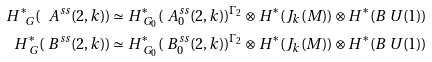Convert formula to latex. <formula><loc_0><loc_0><loc_500><loc_500>H ^ { \ast } _ { \ G } ( \ A ^ { s s } ( 2 , k ) ) & \simeq H ^ { \ast } _ { \ G _ { 0 } } ( \ A ^ { s s } _ { 0 } ( 2 , k ) ) ^ { \Gamma _ { 2 } } \otimes H ^ { \ast } ( J _ { k } ( M ) ) \otimes H ^ { \ast } ( B \ U ( 1 ) ) \\ H ^ { \ast } _ { \ G } ( \ B ^ { s s } ( 2 , k ) ) & \simeq H ^ { \ast } _ { \ G _ { 0 } } ( \ B ^ { s s } _ { 0 } ( 2 , k ) ) ^ { \Gamma _ { 2 } } \otimes H ^ { \ast } ( J _ { k } ( M ) ) \otimes H ^ { \ast } ( B \ U ( 1 ) )</formula> 